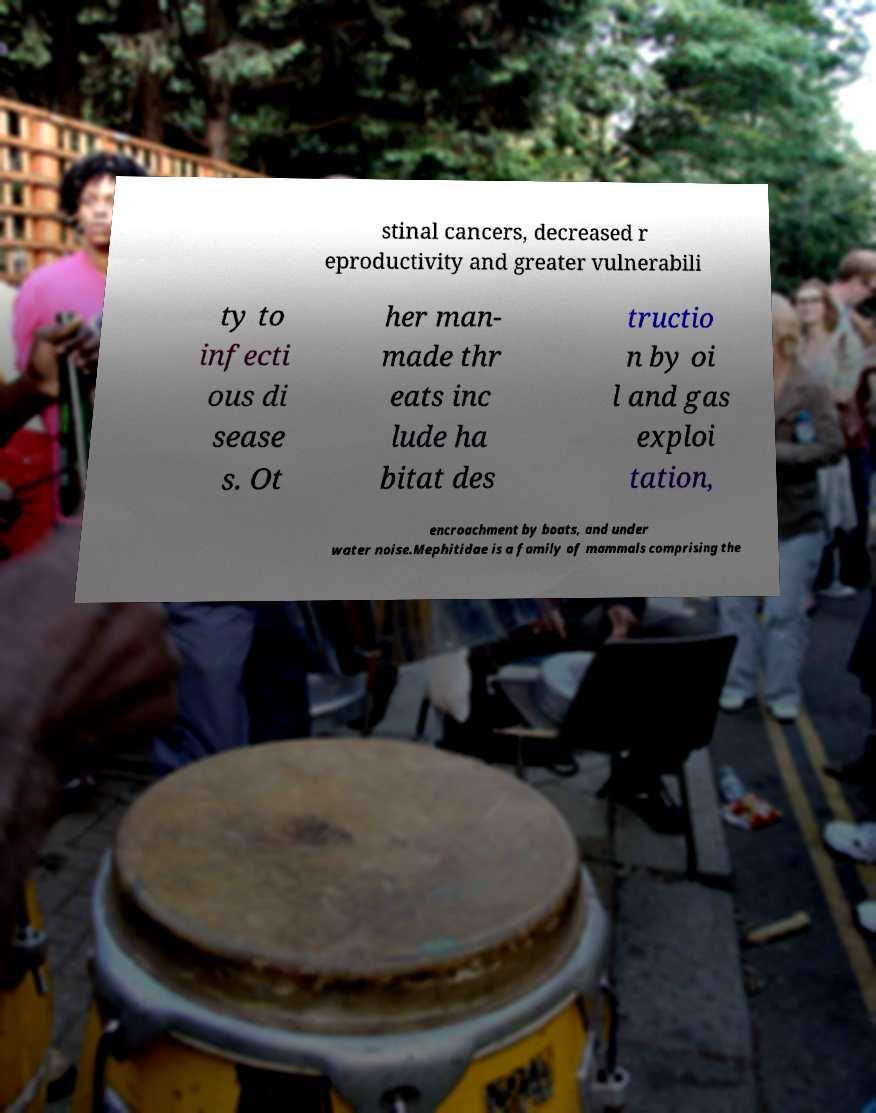Can you read and provide the text displayed in the image?This photo seems to have some interesting text. Can you extract and type it out for me? stinal cancers, decreased r eproductivity and greater vulnerabili ty to infecti ous di sease s. Ot her man- made thr eats inc lude ha bitat des tructio n by oi l and gas exploi tation, encroachment by boats, and under water noise.Mephitidae is a family of mammals comprising the 